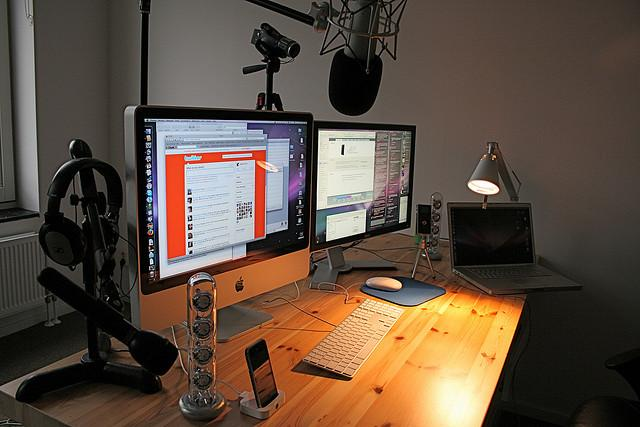What is the wooden item here?

Choices:
A) paddle
B) spoon
C) pirate leg
D) desk desk 